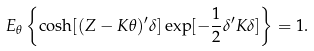<formula> <loc_0><loc_0><loc_500><loc_500>E _ { \theta } \left \{ \cosh [ ( Z - K \theta ) ^ { \prime } \delta ] \exp [ - \frac { 1 } { 2 } \delta ^ { \prime } K \delta ] \right \} = 1 .</formula> 